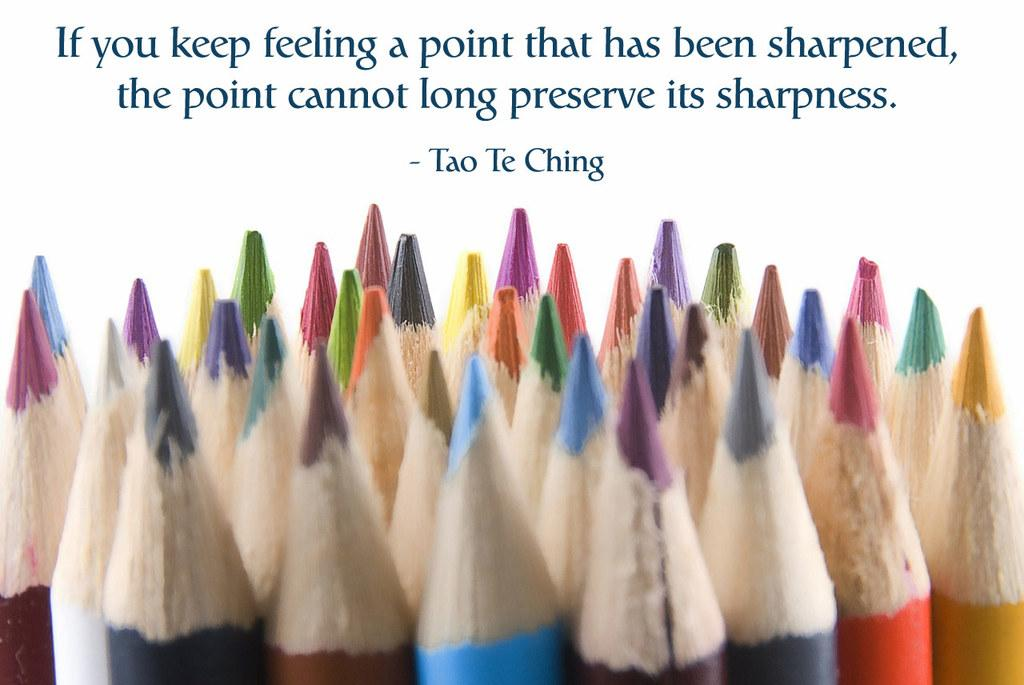What objects are in the foreground of the image? There is a group of color pencils in the foreground of the image. What can be said about the color pencils? The color pencils are of different colors. What is visible at the top of the image? There is text visible at the top of the image. What type of insect can be seen cooking in the image? There is no insect or cooking activity present in the image. What kind of beetle is crawling on the color pencils in the image? There are no beetles or insects present in the image; it only features a group of color pencils. 